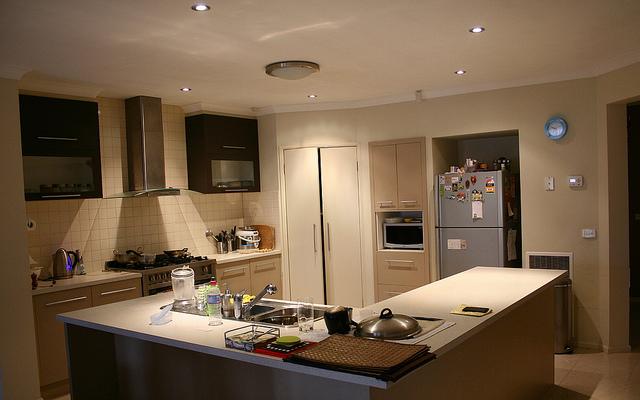Is the water turned on or off?
Give a very brief answer. Off. What room is this?
Keep it brief. Kitchen. Where is the microwave?
Quick response, please. Next to refrigerator. Is there a paper towel holder?
Give a very brief answer. No. 